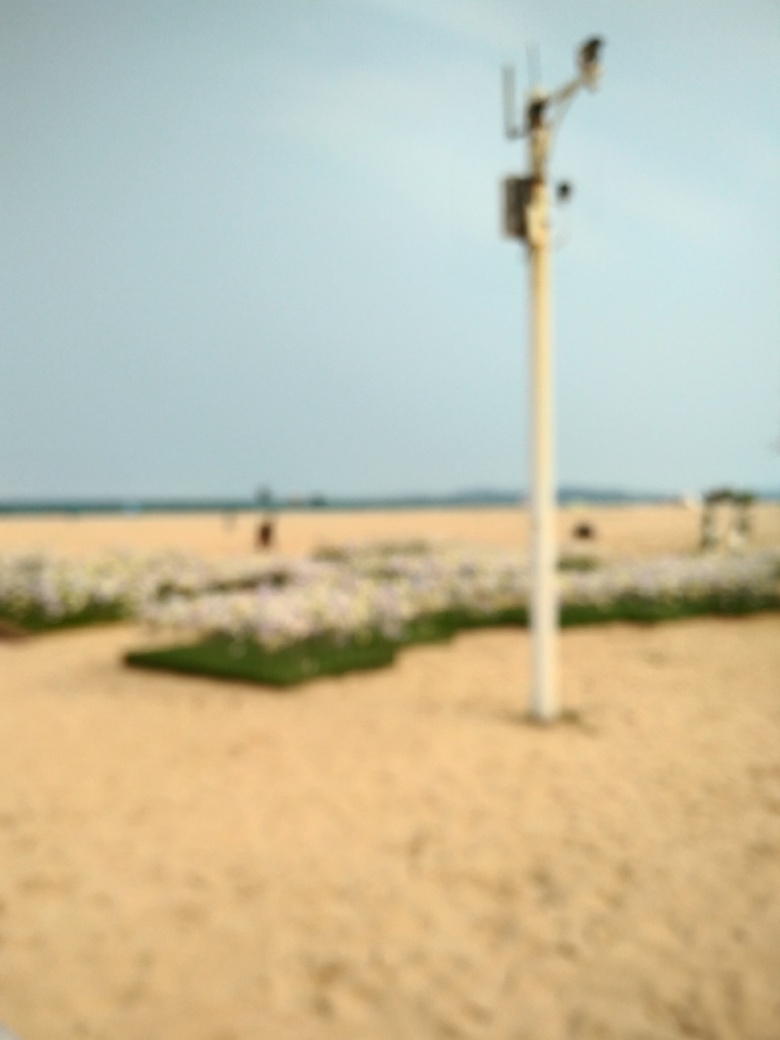Is the image free from blurriness?
A. No
B. Yes
Answer with the option's letter from the given choices directly.
 A. 